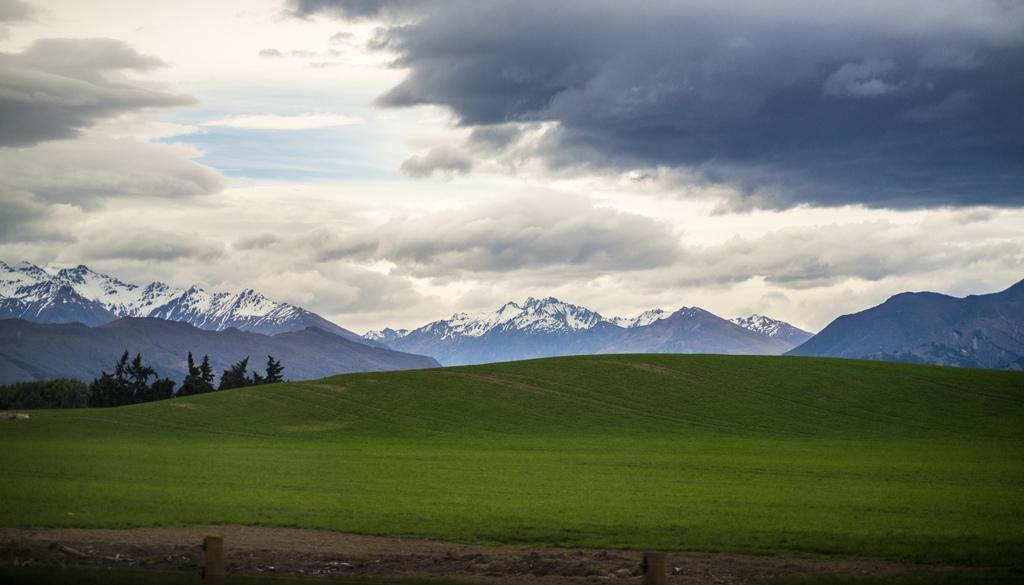Please provide a concise description of this image. In the background of the image there are mountains with snow. In the center of the image there is grass. At the top of the image there is sky and clouds. There are trees. 